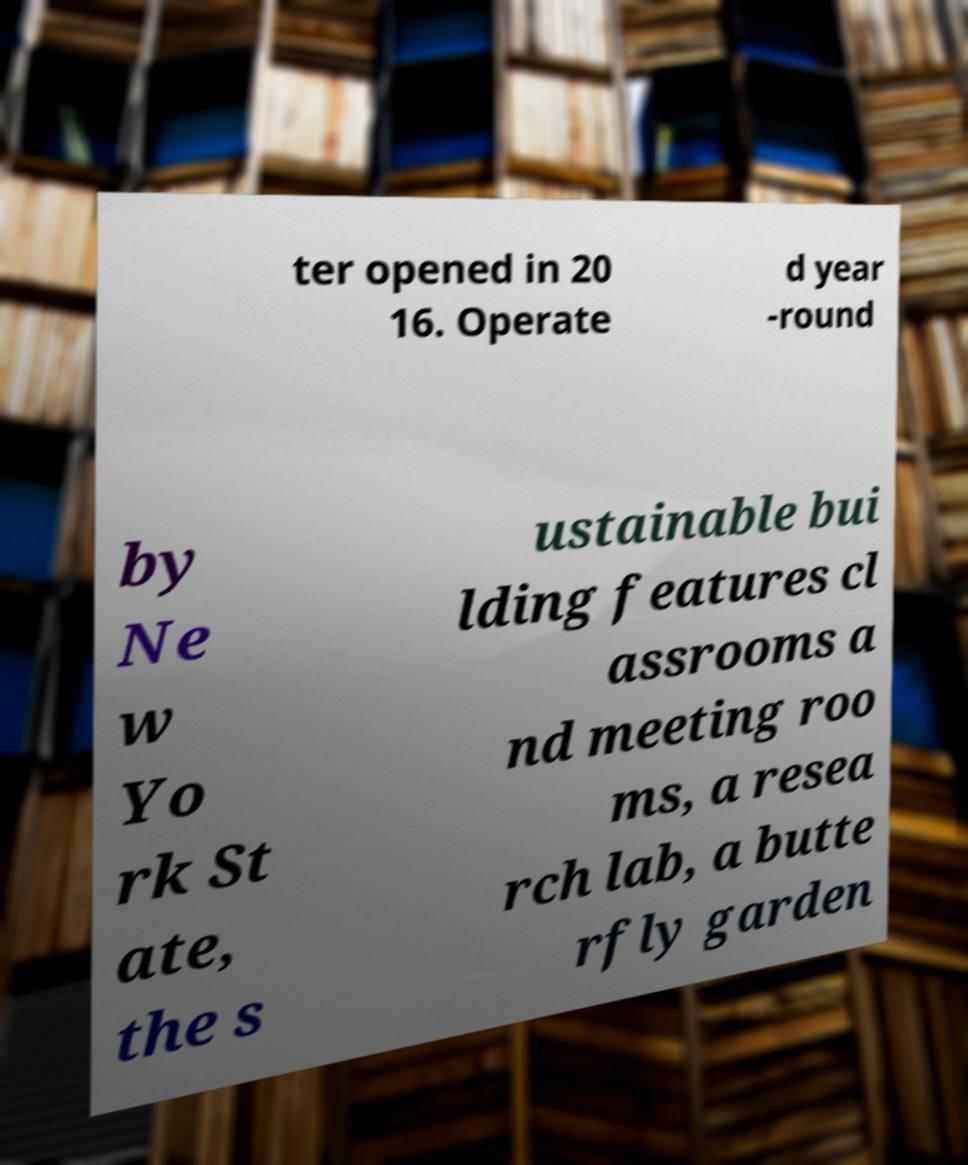Please read and relay the text visible in this image. What does it say? ter opened in 20 16. Operate d year -round by Ne w Yo rk St ate, the s ustainable bui lding features cl assrooms a nd meeting roo ms, a resea rch lab, a butte rfly garden 